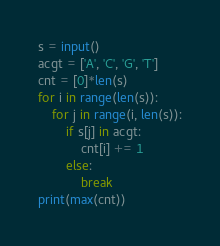Convert code to text. <code><loc_0><loc_0><loc_500><loc_500><_Python_>s = input()
acgt = ['A', 'C', 'G', 'T']
cnt = [0]*len(s)
for i in range(len(s)):
    for j in range(i, len(s)):
        if s[j] in acgt:
            cnt[i] += 1
        else:
            break
print(max(cnt))</code> 